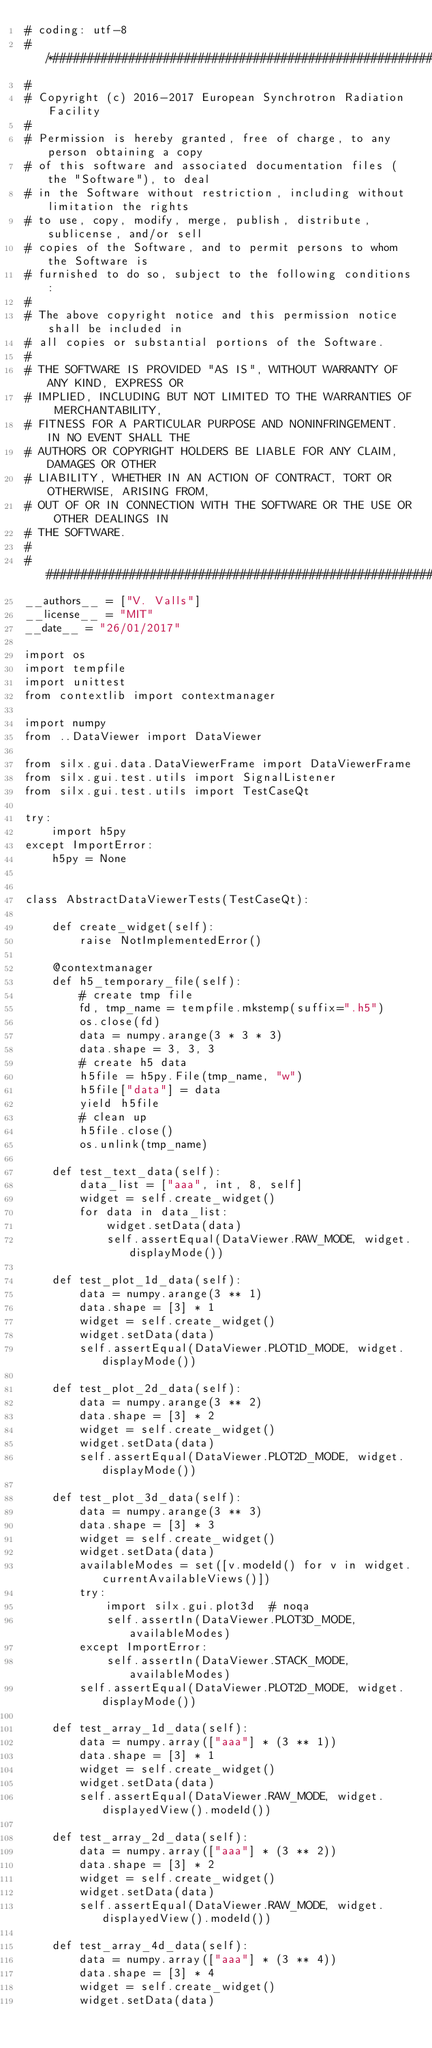Convert code to text. <code><loc_0><loc_0><loc_500><loc_500><_Python_># coding: utf-8
# /*##########################################################################
#
# Copyright (c) 2016-2017 European Synchrotron Radiation Facility
#
# Permission is hereby granted, free of charge, to any person obtaining a copy
# of this software and associated documentation files (the "Software"), to deal
# in the Software without restriction, including without limitation the rights
# to use, copy, modify, merge, publish, distribute, sublicense, and/or sell
# copies of the Software, and to permit persons to whom the Software is
# furnished to do so, subject to the following conditions:
#
# The above copyright notice and this permission notice shall be included in
# all copies or substantial portions of the Software.
#
# THE SOFTWARE IS PROVIDED "AS IS", WITHOUT WARRANTY OF ANY KIND, EXPRESS OR
# IMPLIED, INCLUDING BUT NOT LIMITED TO THE WARRANTIES OF MERCHANTABILITY,
# FITNESS FOR A PARTICULAR PURPOSE AND NONINFRINGEMENT. IN NO EVENT SHALL THE
# AUTHORS OR COPYRIGHT HOLDERS BE LIABLE FOR ANY CLAIM, DAMAGES OR OTHER
# LIABILITY, WHETHER IN AN ACTION OF CONTRACT, TORT OR OTHERWISE, ARISING FROM,
# OUT OF OR IN CONNECTION WITH THE SOFTWARE OR THE USE OR OTHER DEALINGS IN
# THE SOFTWARE.
#
# ###########################################################################*/
__authors__ = ["V. Valls"]
__license__ = "MIT"
__date__ = "26/01/2017"

import os
import tempfile
import unittest
from contextlib import contextmanager

import numpy
from ..DataViewer import DataViewer

from silx.gui.data.DataViewerFrame import DataViewerFrame
from silx.gui.test.utils import SignalListener
from silx.gui.test.utils import TestCaseQt

try:
    import h5py
except ImportError:
    h5py = None


class AbstractDataViewerTests(TestCaseQt):

    def create_widget(self):
        raise NotImplementedError()

    @contextmanager
    def h5_temporary_file(self):
        # create tmp file
        fd, tmp_name = tempfile.mkstemp(suffix=".h5")
        os.close(fd)
        data = numpy.arange(3 * 3 * 3)
        data.shape = 3, 3, 3
        # create h5 data
        h5file = h5py.File(tmp_name, "w")
        h5file["data"] = data
        yield h5file
        # clean up
        h5file.close()
        os.unlink(tmp_name)

    def test_text_data(self):
        data_list = ["aaa", int, 8, self]
        widget = self.create_widget()
        for data in data_list:
            widget.setData(data)
            self.assertEqual(DataViewer.RAW_MODE, widget.displayMode())

    def test_plot_1d_data(self):
        data = numpy.arange(3 ** 1)
        data.shape = [3] * 1
        widget = self.create_widget()
        widget.setData(data)
        self.assertEqual(DataViewer.PLOT1D_MODE, widget.displayMode())

    def test_plot_2d_data(self):
        data = numpy.arange(3 ** 2)
        data.shape = [3] * 2
        widget = self.create_widget()
        widget.setData(data)
        self.assertEqual(DataViewer.PLOT2D_MODE, widget.displayMode())

    def test_plot_3d_data(self):
        data = numpy.arange(3 ** 3)
        data.shape = [3] * 3
        widget = self.create_widget()
        widget.setData(data)
        availableModes = set([v.modeId() for v in widget.currentAvailableViews()])
        try:
            import silx.gui.plot3d  # noqa
            self.assertIn(DataViewer.PLOT3D_MODE, availableModes)
        except ImportError:
            self.assertIn(DataViewer.STACK_MODE, availableModes)
        self.assertEqual(DataViewer.PLOT2D_MODE, widget.displayMode())

    def test_array_1d_data(self):
        data = numpy.array(["aaa"] * (3 ** 1))
        data.shape = [3] * 1
        widget = self.create_widget()
        widget.setData(data)
        self.assertEqual(DataViewer.RAW_MODE, widget.displayedView().modeId())

    def test_array_2d_data(self):
        data = numpy.array(["aaa"] * (3 ** 2))
        data.shape = [3] * 2
        widget = self.create_widget()
        widget.setData(data)
        self.assertEqual(DataViewer.RAW_MODE, widget.displayedView().modeId())

    def test_array_4d_data(self):
        data = numpy.array(["aaa"] * (3 ** 4))
        data.shape = [3] * 4
        widget = self.create_widget()
        widget.setData(data)</code> 